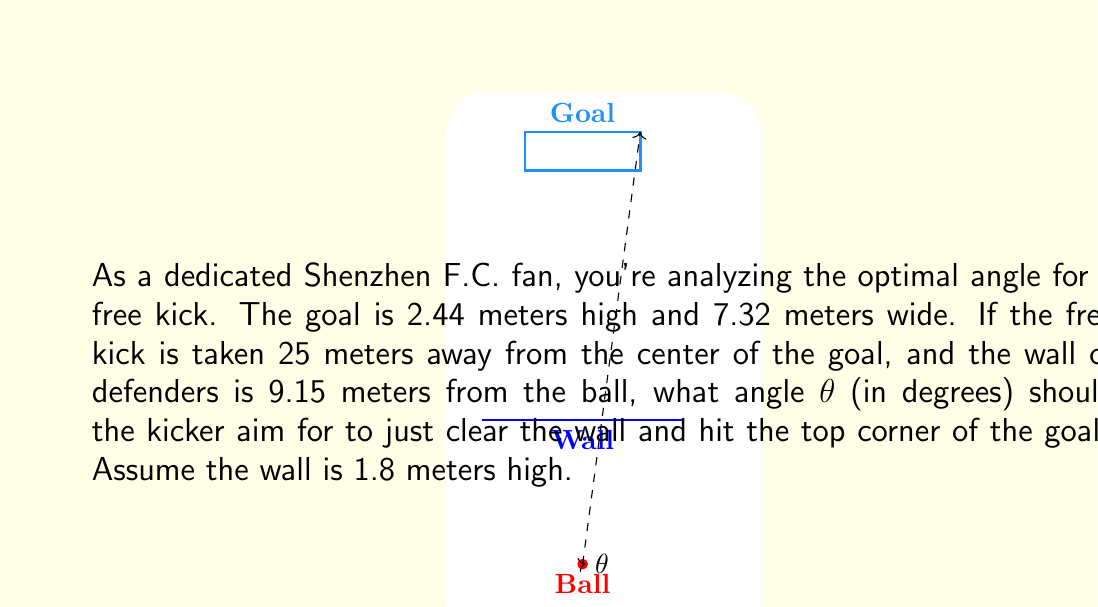Help me with this question. Let's approach this step-by-step:

1) First, we need to find the height difference between the top of the wall and the top corner of the goal:
   $\Delta h = 2.44m - 1.8m = 0.64m$

2) The horizontal distance from the wall to the goal is:
   $25m - 9.15m = 15.85m$

3) We can now consider this as a right triangle, where:
   - The adjacent side is 15.85m (horizontal distance from wall to goal)
   - The opposite side is 0.64m (height difference)
   - The angle we're looking for is at the ball position

4) We can use the tangent function to find this angle:

   $$\tan(\theta) = \frac{opposite}{adjacent} = \frac{0.64}{15.85}$$

5) To solve for θ, we use the inverse tangent (arctan) function:

   $$\theta = \arctan(\frac{0.64}{15.85})$$

6) Converting this to degrees:

   $$\theta = \arctan(\frac{0.64}{15.85}) * \frac{180}{\pi} \approx 2.31°$$

7) However, this angle would hit the center of the goal. To hit the top corner, we need to account for half the width of the goal:

   Horizontal angle: $\arctan(\frac{3.66}{25}) * \frac{180}{\pi} \approx 8.32°$

8) The total angle is the sum of these two angles:

   $$\theta_{total} = 2.31° + 8.32° \approx 10.63°$$
Answer: $10.63°$ 